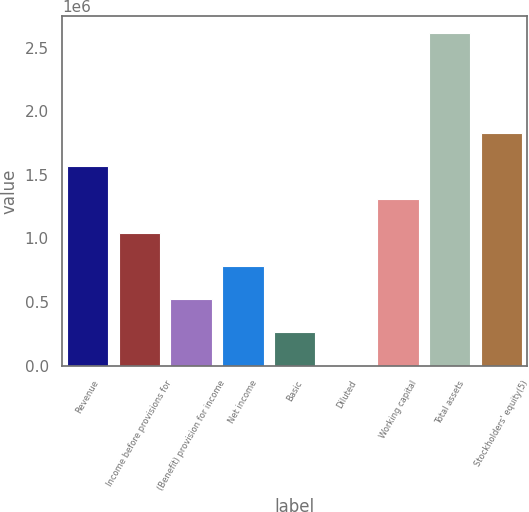<chart> <loc_0><loc_0><loc_500><loc_500><bar_chart><fcel>Revenue<fcel>Income before provisions for<fcel>(Benefit) provision for income<fcel>Net income<fcel>Basic<fcel>Diluted<fcel>Working capital<fcel>Total assets<fcel>Stockholders' equity(5)<nl><fcel>1.5704e+06<fcel>1.04694e+06<fcel>523468<fcel>785202<fcel>261734<fcel>0.87<fcel>1.30867e+06<fcel>2.61734e+06<fcel>1.83214e+06<nl></chart> 